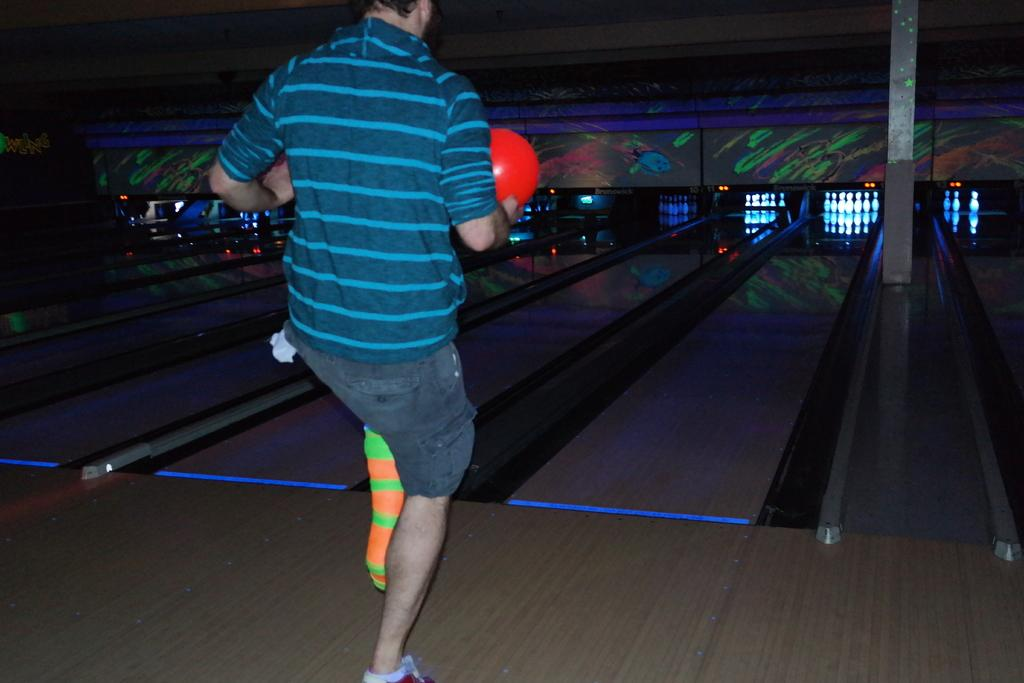What is the main subject of the image? There is a person in the image. What is the person wearing? The person is wearing clothes. What activity is the person engaged in? The person is playing ten pin bowling. What type of chair is the person sitting on while playing ten pin bowling? There is no chair present in the image; the person is standing while playing ten pin bowling. 